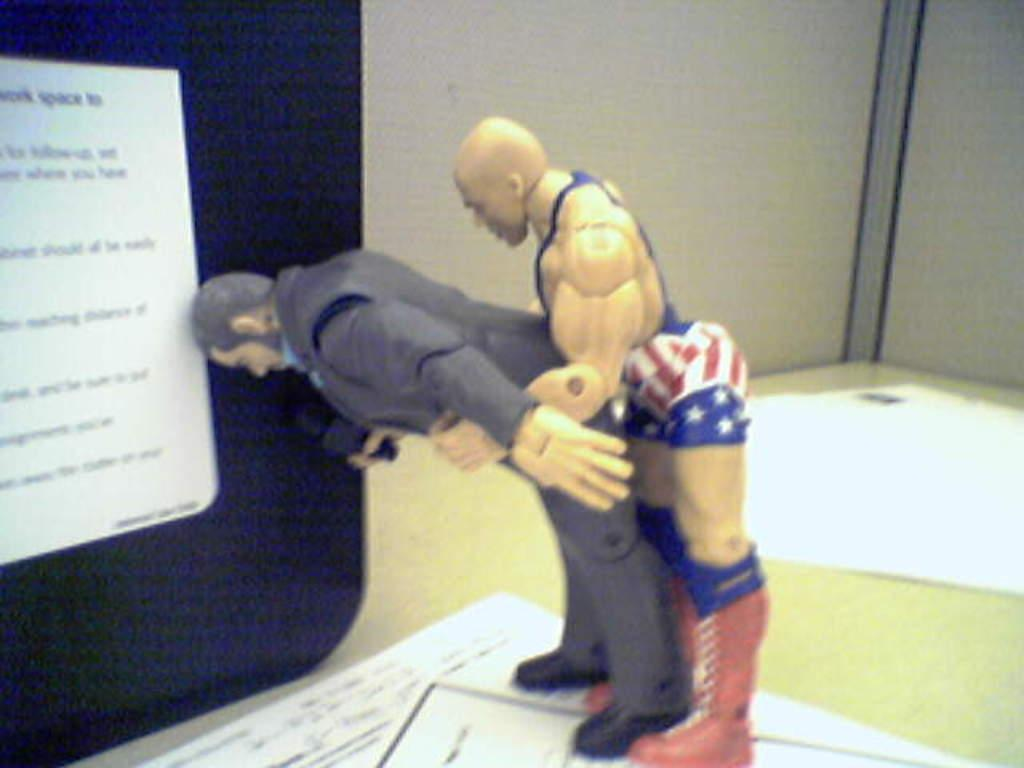What objects are present in the image? There are two toys in the image. What are the toys standing on? The toys are standing on papers. What can be seen in the background of the image? There is a board on a table in the background of the image. What type of dress is the farmer wearing in the image? There is no farmer or dress present in the image; it features two toys standing on papers. 